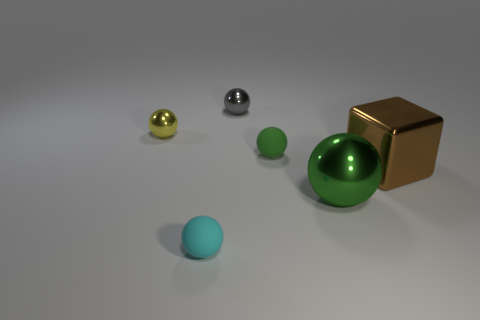Subtract all small yellow shiny balls. How many balls are left? 4 Add 3 tiny shiny cubes. How many objects exist? 9 Subtract all cyan balls. How many balls are left? 4 Add 6 tiny purple matte objects. How many tiny purple matte objects exist? 6 Subtract 0 red blocks. How many objects are left? 6 Subtract all balls. How many objects are left? 1 Subtract 5 balls. How many balls are left? 0 Subtract all yellow cubes. Subtract all purple cylinders. How many cubes are left? 1 Subtract all green cubes. How many blue spheres are left? 0 Subtract all small gray rubber objects. Subtract all metallic balls. How many objects are left? 3 